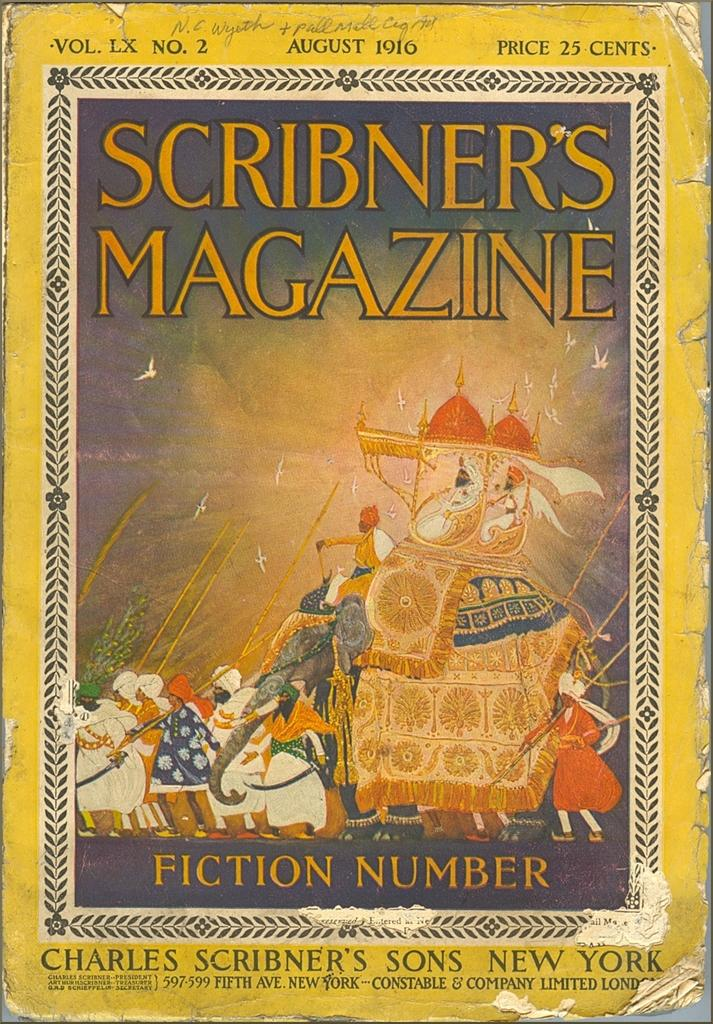What is the main subject of the image? The main subject of the image is the cover page of a book. Can you describe any specific details about the cover page? Unfortunately, the provided facts do not include any specific details about the cover page. How many rabbits are visible on the cover page of the book in the image? There are no rabbits present on the cover page of the book in the image. What type of government is depicted on the cover page of the book in the image? There is no information about any government being depicted on the cover page of the book in the image. 